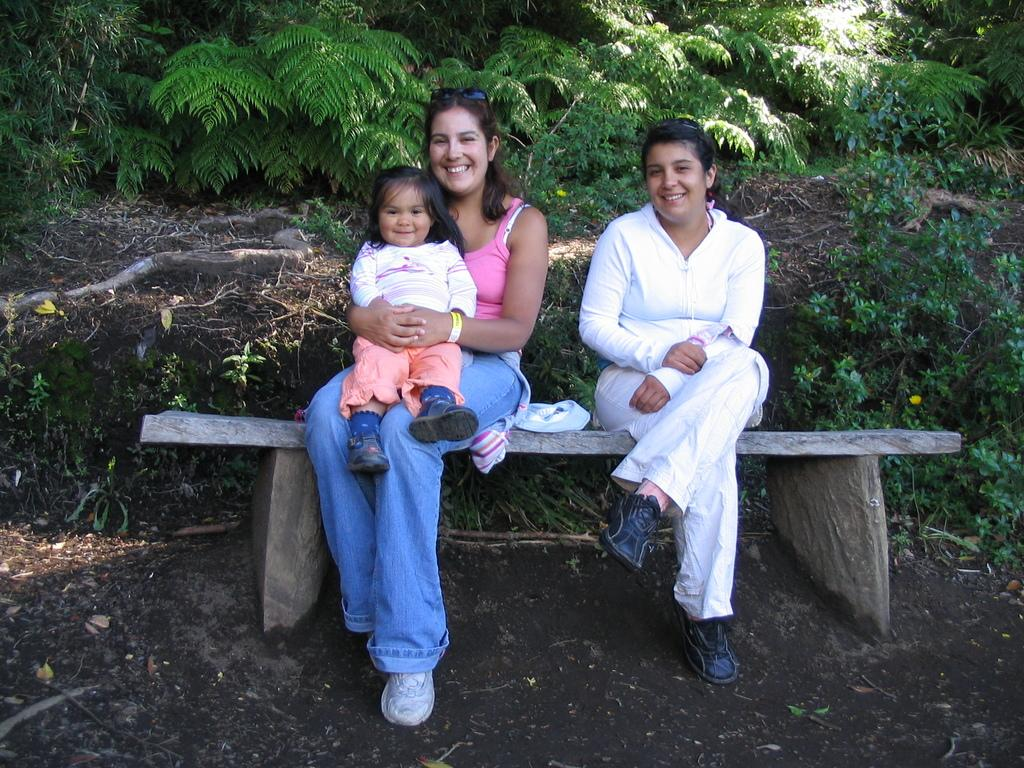How many women are in the image? There are two women in the image. What are the women doing in the image? The women are sitting on a bench. Is there a baby present in the image? Yes, the woman on the left is holding a baby. What can be seen in the background of the image? There are plants visible in the background of the image. What type of soap is the baby using in the image? There is no soap present in the image; the baby is being held by one of the women. Where is the sheet located in the image? There is no sheet present in the image. 